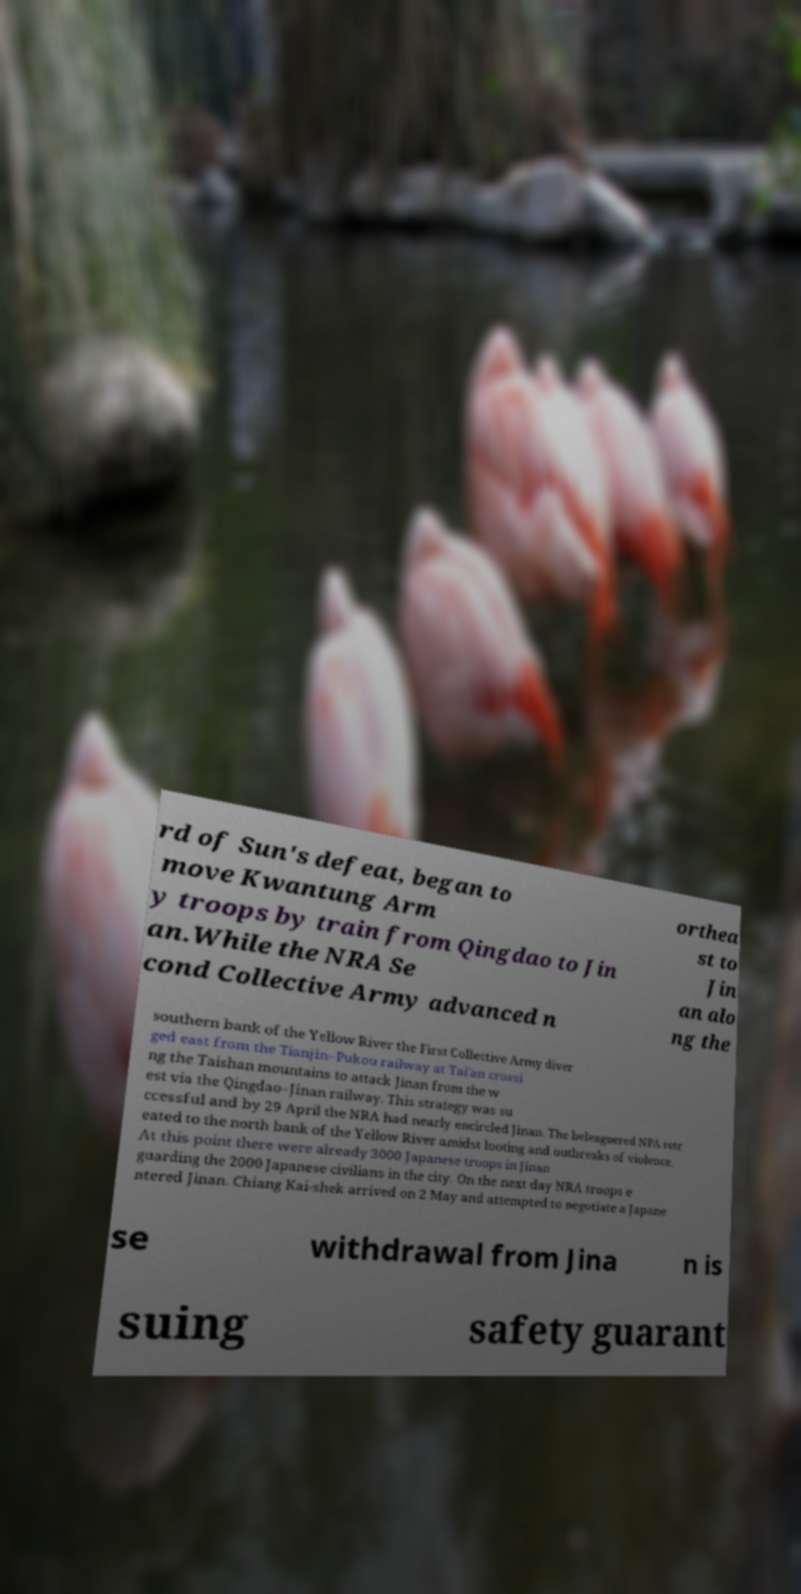For documentation purposes, I need the text within this image transcribed. Could you provide that? rd of Sun's defeat, began to move Kwantung Arm y troops by train from Qingdao to Jin an.While the NRA Se cond Collective Army advanced n orthea st to Jin an alo ng the southern bank of the Yellow River the First Collective Army diver ged east from the Tianjin–Pukou railway at Tai'an crossi ng the Taishan mountains to attack Jinan from the w est via the Qingdao–Jinan railway. This strategy was su ccessful and by 29 April the NRA had nearly encircled Jinan. The beleaguered NPA retr eated to the north bank of the Yellow River amidst looting and outbreaks of violence. At this point there were already 3000 Japanese troops in Jinan guarding the 2000 Japanese civilians in the city. On the next day NRA troops e ntered Jinan. Chiang Kai-shek arrived on 2 May and attempted to negotiate a Japane se withdrawal from Jina n is suing safety guarant 